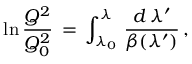Convert formula to latex. <formula><loc_0><loc_0><loc_500><loc_500>\ln \frac { Q ^ { 2 } } { Q _ { 0 } ^ { 2 } } \, = \, \int _ { { \lambda } _ { 0 } } ^ { \lambda } \, \frac { d \, { \lambda } ^ { \prime } } { { \beta } ( { \lambda } ^ { \prime } ) } \, ,</formula> 